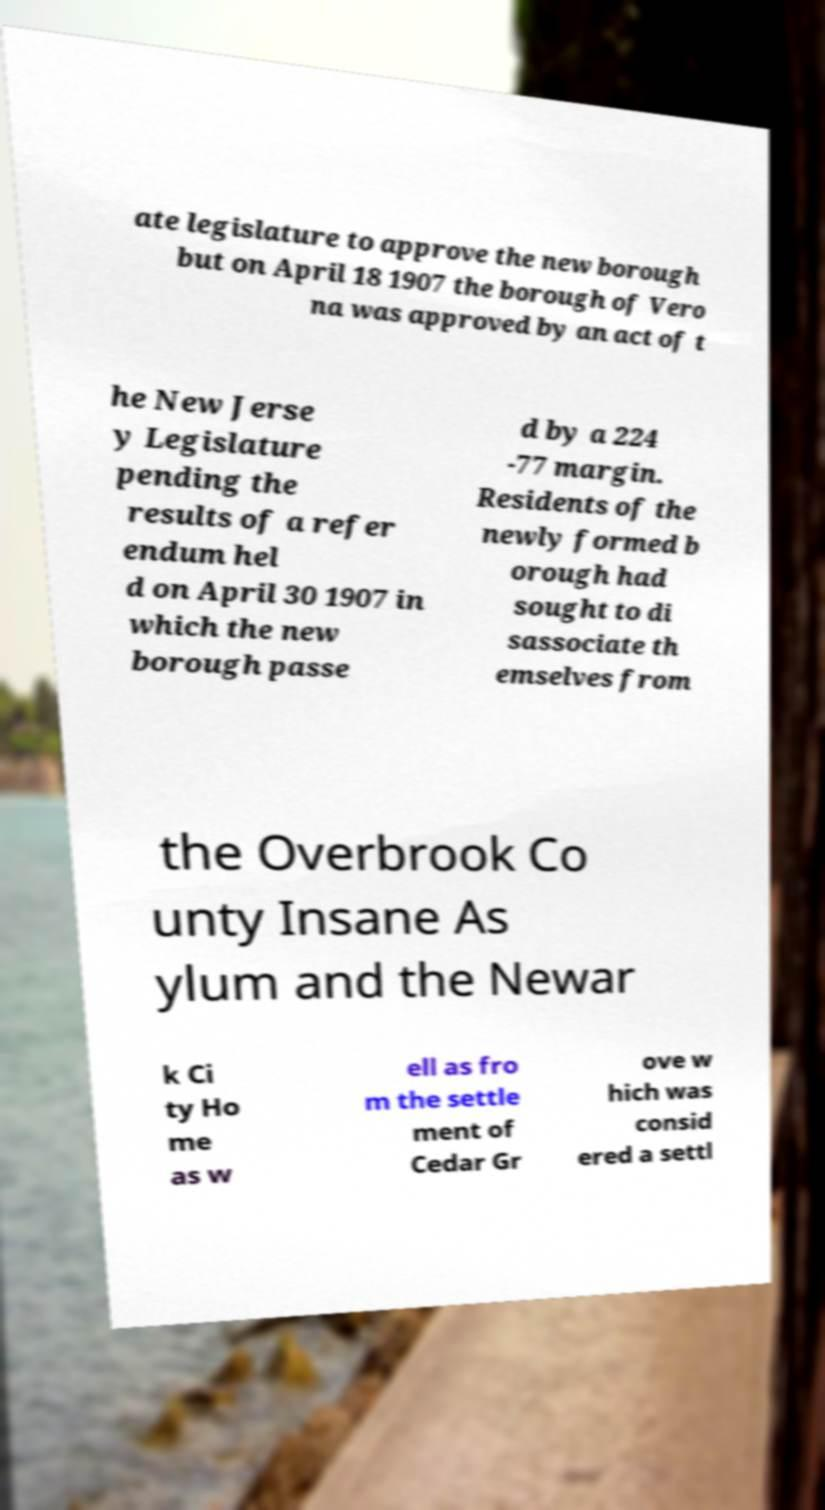I need the written content from this picture converted into text. Can you do that? ate legislature to approve the new borough but on April 18 1907 the borough of Vero na was approved by an act of t he New Jerse y Legislature pending the results of a refer endum hel d on April 30 1907 in which the new borough passe d by a 224 -77 margin. Residents of the newly formed b orough had sought to di sassociate th emselves from the Overbrook Co unty Insane As ylum and the Newar k Ci ty Ho me as w ell as fro m the settle ment of Cedar Gr ove w hich was consid ered a settl 